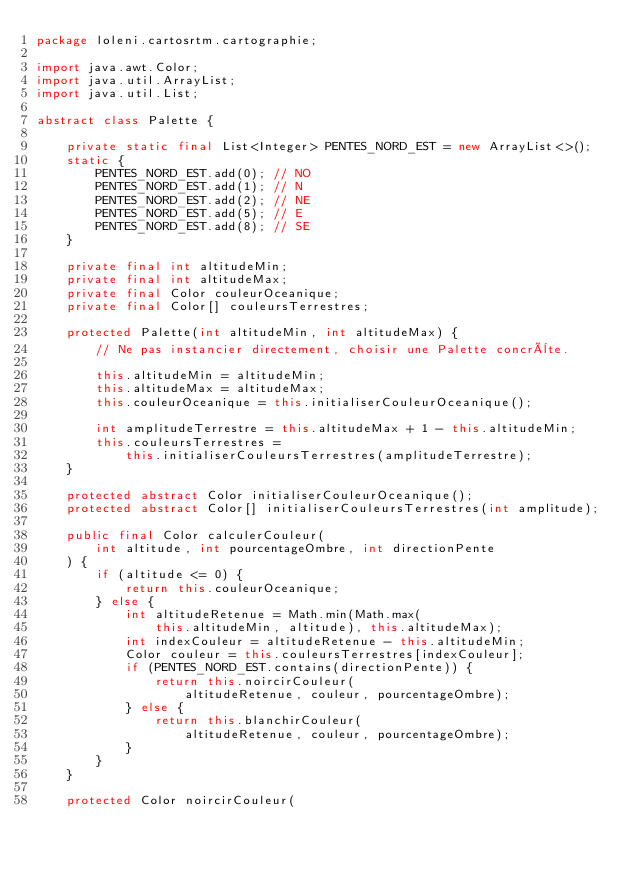<code> <loc_0><loc_0><loc_500><loc_500><_Java_>package loleni.cartosrtm.cartographie;

import java.awt.Color;
import java.util.ArrayList;
import java.util.List;

abstract class Palette {

    private static final List<Integer> PENTES_NORD_EST = new ArrayList<>();
    static {
        PENTES_NORD_EST.add(0); // NO
        PENTES_NORD_EST.add(1); // N
        PENTES_NORD_EST.add(2); // NE
        PENTES_NORD_EST.add(5); // E
        PENTES_NORD_EST.add(8); // SE
    }

    private final int altitudeMin;
    private final int altitudeMax;
    private final Color couleurOceanique;
    private final Color[] couleursTerrestres;

    protected Palette(int altitudeMin, int altitudeMax) {
        // Ne pas instancier directement, choisir une Palette concrète.

        this.altitudeMin = altitudeMin;
        this.altitudeMax = altitudeMax;
        this.couleurOceanique = this.initialiserCouleurOceanique();

        int amplitudeTerrestre = this.altitudeMax + 1 - this.altitudeMin;
        this.couleursTerrestres =
            this.initialiserCouleursTerrestres(amplitudeTerrestre);
    }

    protected abstract Color initialiserCouleurOceanique();
    protected abstract Color[] initialiserCouleursTerrestres(int amplitude);

    public final Color calculerCouleur(
        int altitude, int pourcentageOmbre, int directionPente
    ) {
        if (altitude <= 0) {
            return this.couleurOceanique;
        } else {
            int altitudeRetenue = Math.min(Math.max(
                this.altitudeMin, altitude), this.altitudeMax);
            int indexCouleur = altitudeRetenue - this.altitudeMin;
            Color couleur = this.couleursTerrestres[indexCouleur];
            if (PENTES_NORD_EST.contains(directionPente)) {
                return this.noircirCouleur(
                    altitudeRetenue, couleur, pourcentageOmbre);
            } else {
                return this.blanchirCouleur(
                    altitudeRetenue, couleur, pourcentageOmbre);
            }
        }
    }

    protected Color noircirCouleur(</code> 